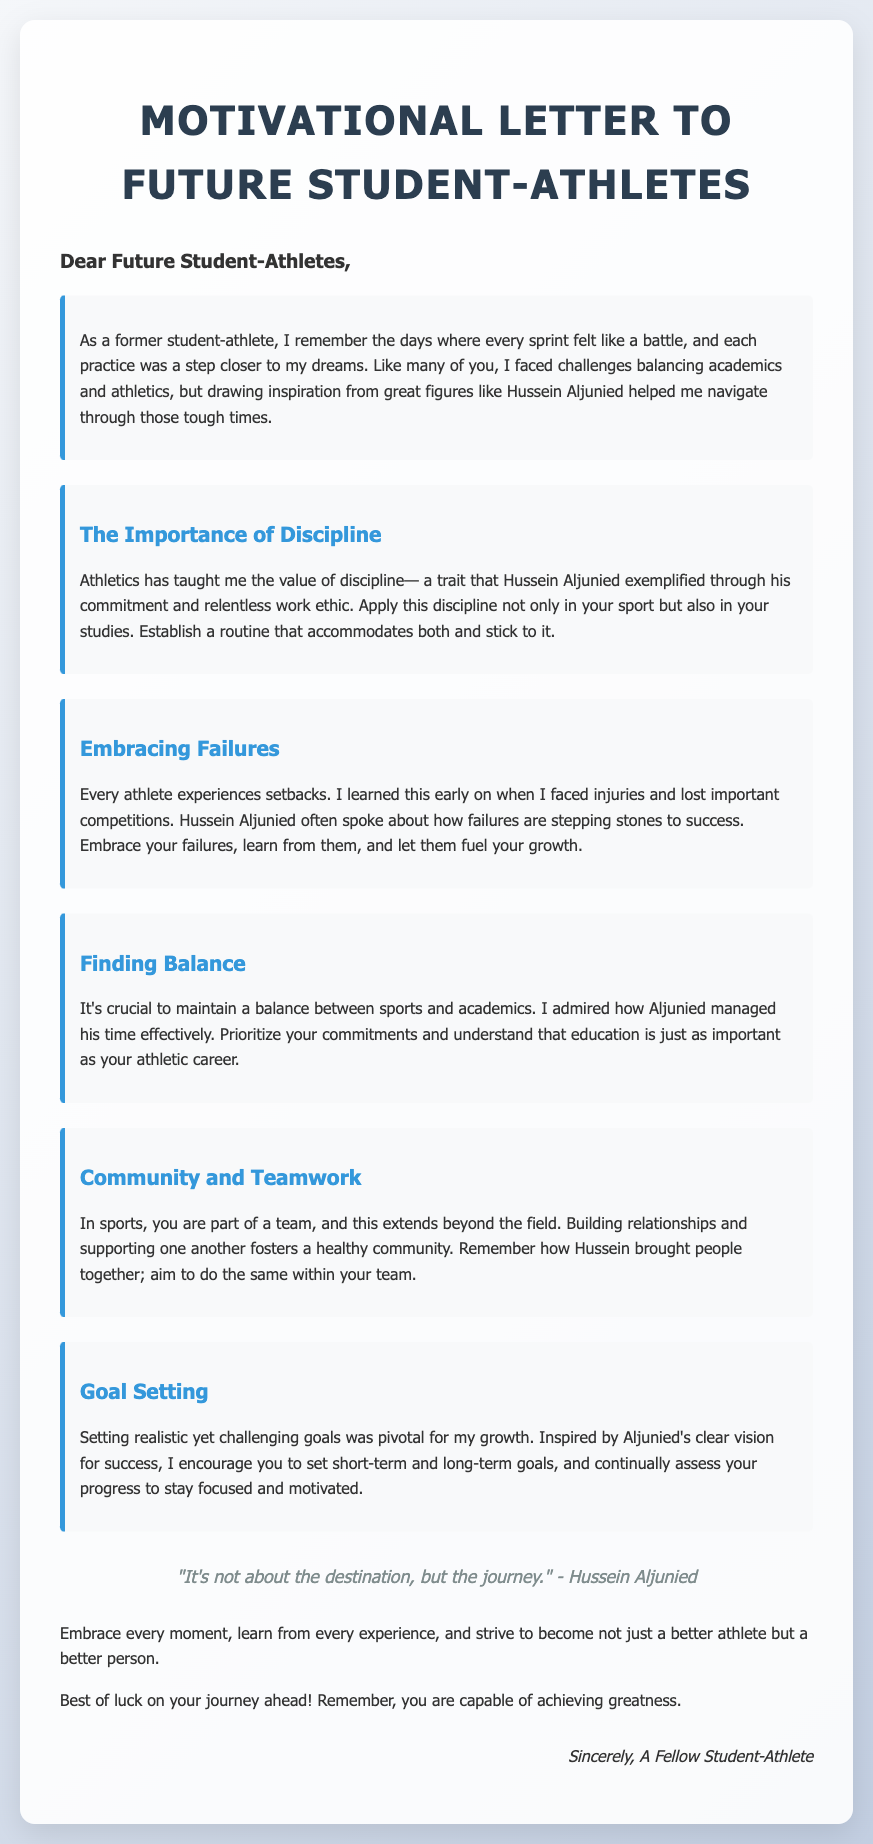What is the title of the document? The title is found within the header section of the document, which clearly states "Motivational Letter to Future Student-Athletes."
Answer: Motivational Letter to Future Student-Athletes Who is the motivational letter addressed to? The greeting at the beginning of the letter indicates that it is addressed to future student-athletes.
Answer: Future Student-Athletes What is a key trait emphasized in the letter? The letter highlights discipline as a key trait, specifically mentioning how Hussein Aljunied exemplified this through his commitment.
Answer: Discipline What quote is included in the letter? The quote appears in the section dedicated to inspiring the readers, attributed to Hussein Aljunied, stating, "It's not about the destination, but the journey."
Answer: "It's not about the destination, but the journey." What does the letter say about balancing sports and academics? The author emphasizes the importance of maintaining balance, inspired by Aljunied's effective time management skills.
Answer: Maintain a balance How many sections are dedicated to different themes in the letter? The document features five different sections that each address specific themes relating to student-athlete experiences.
Answer: Five What did the author learn about failures? The author references Hussein Aljunied’s philosophy that failures act as stepping stones to success, indicating a positive outlook on setbacks.
Answer: Failures are stepping stones What is the final message to future student-athletes? The closing remarks encapsulate a motivational farewell, encouraging readers to embrace their journey and strive for greatness.
Answer: You are capable of achieving greatness 